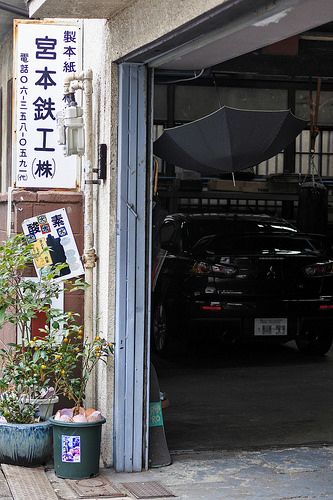<image>
Is the umbrella above the car? Yes. The umbrella is positioned above the car in the vertical space, higher up in the scene. 